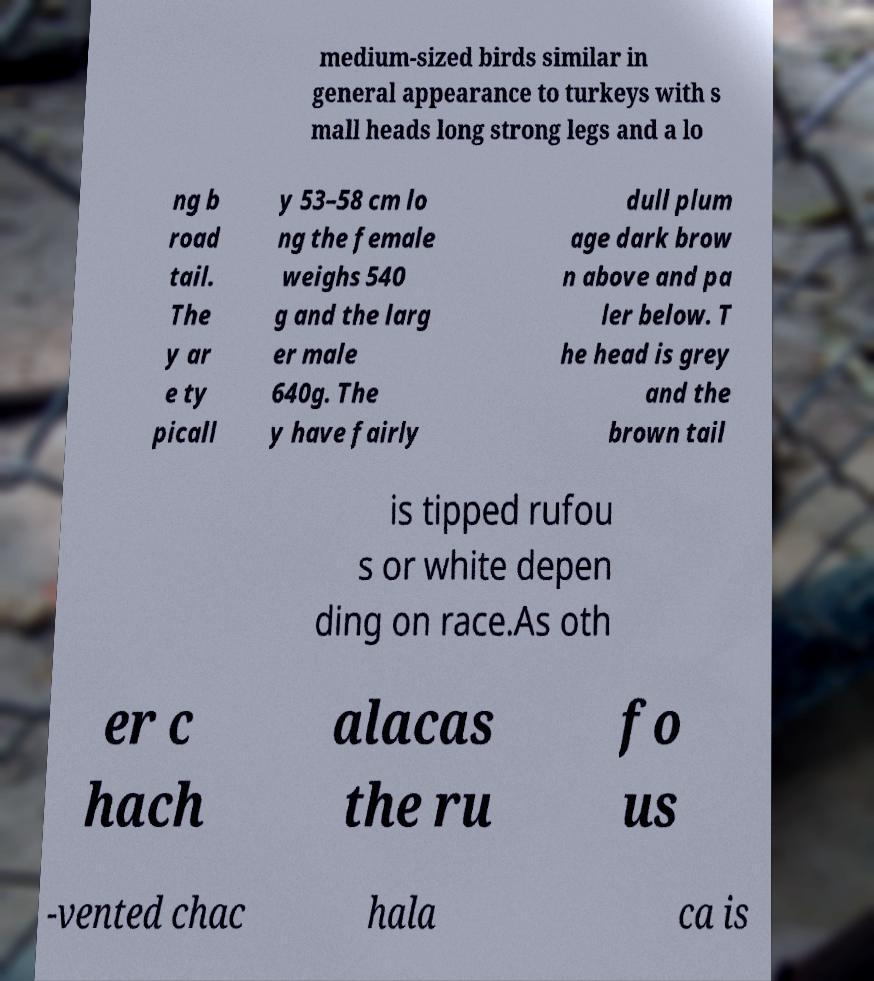I need the written content from this picture converted into text. Can you do that? medium-sized birds similar in general appearance to turkeys with s mall heads long strong legs and a lo ng b road tail. The y ar e ty picall y 53–58 cm lo ng the female weighs 540 g and the larg er male 640g. The y have fairly dull plum age dark brow n above and pa ler below. T he head is grey and the brown tail is tipped rufou s or white depen ding on race.As oth er c hach alacas the ru fo us -vented chac hala ca is 